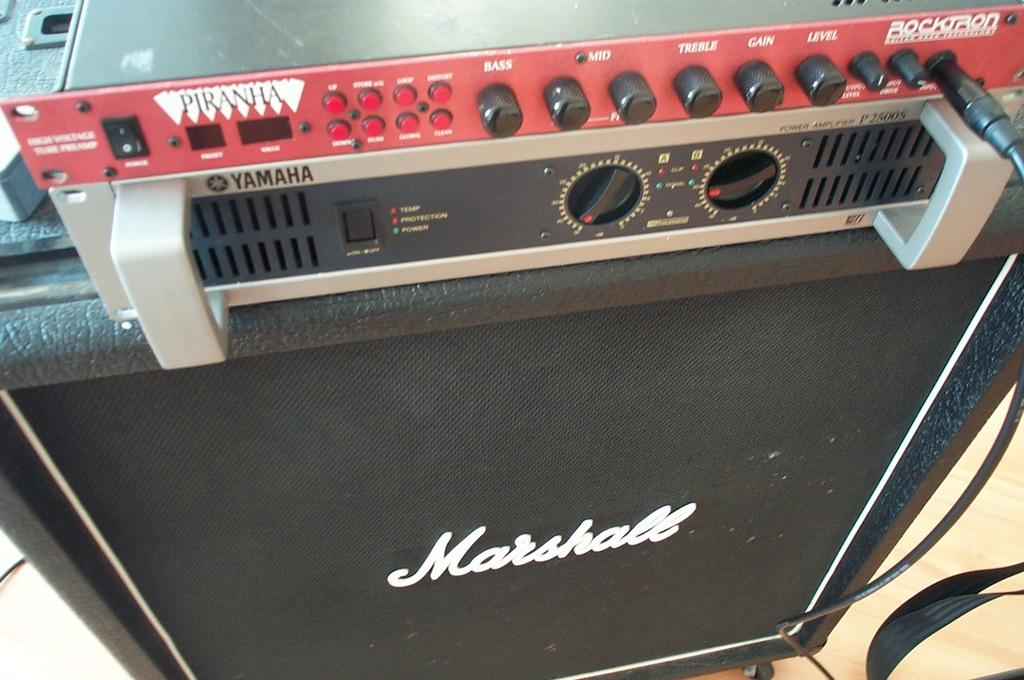<image>
Offer a succinct explanation of the picture presented. An amplifier with many dials is made by the Marshall company. 